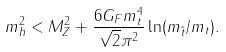<formula> <loc_0><loc_0><loc_500><loc_500>m _ { h } ^ { 2 } < M _ { Z } ^ { 2 } + \frac { 6 G _ { F } m _ { t } ^ { 4 } } { \sqrt { 2 } \pi ^ { 2 } } \ln ( m _ { \tilde { t } } / m _ { t } ) .</formula> 